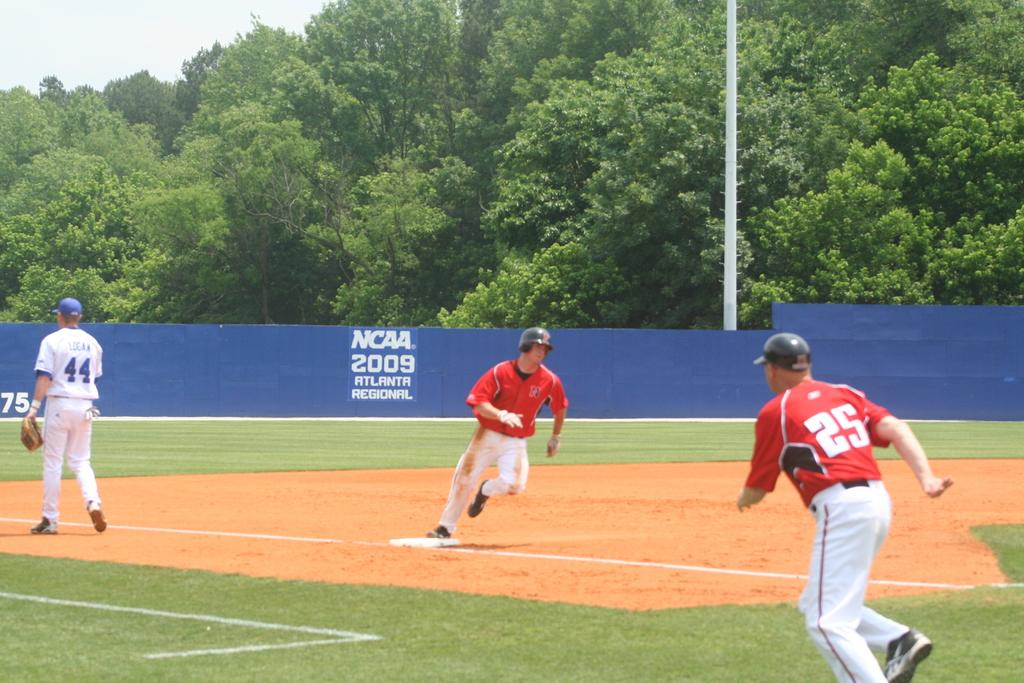<image>
Share a concise interpretation of the image provided. Player number 44 walks toward third base as player 25 runs. 